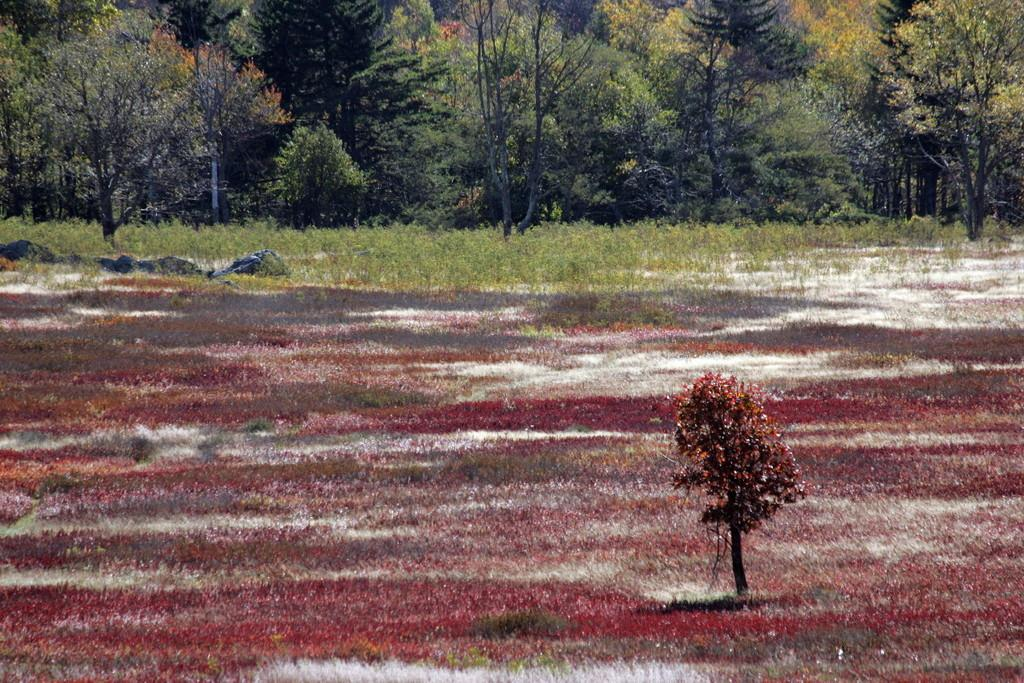What type of flowers can be seen in the image? There are red color flowers in the image. What is the condition of the ground in the image? There is snow on the ground in the image. What is the purpose of the plant hire in the image? The plant hire is likely used for planting or maintaining the plants visible in the image. What other elements can be seen in the image besides the flowers? There are plants, stones, and trees visible in the image. Can you see a clam in the image? There is no clam present in the image. What type of toothbrush is being used to water the plants in the image? There is no toothbrush visible in the image, and it is not being used to water the plants. 